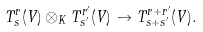<formula> <loc_0><loc_0><loc_500><loc_500>T _ { s } ^ { r } ( V ) \otimes _ { K } T _ { s ^ { \prime } } ^ { r ^ { \prime } } ( V ) \to T _ { s + s ^ { \prime } } ^ { r + r ^ { \prime } } ( V ) .</formula> 